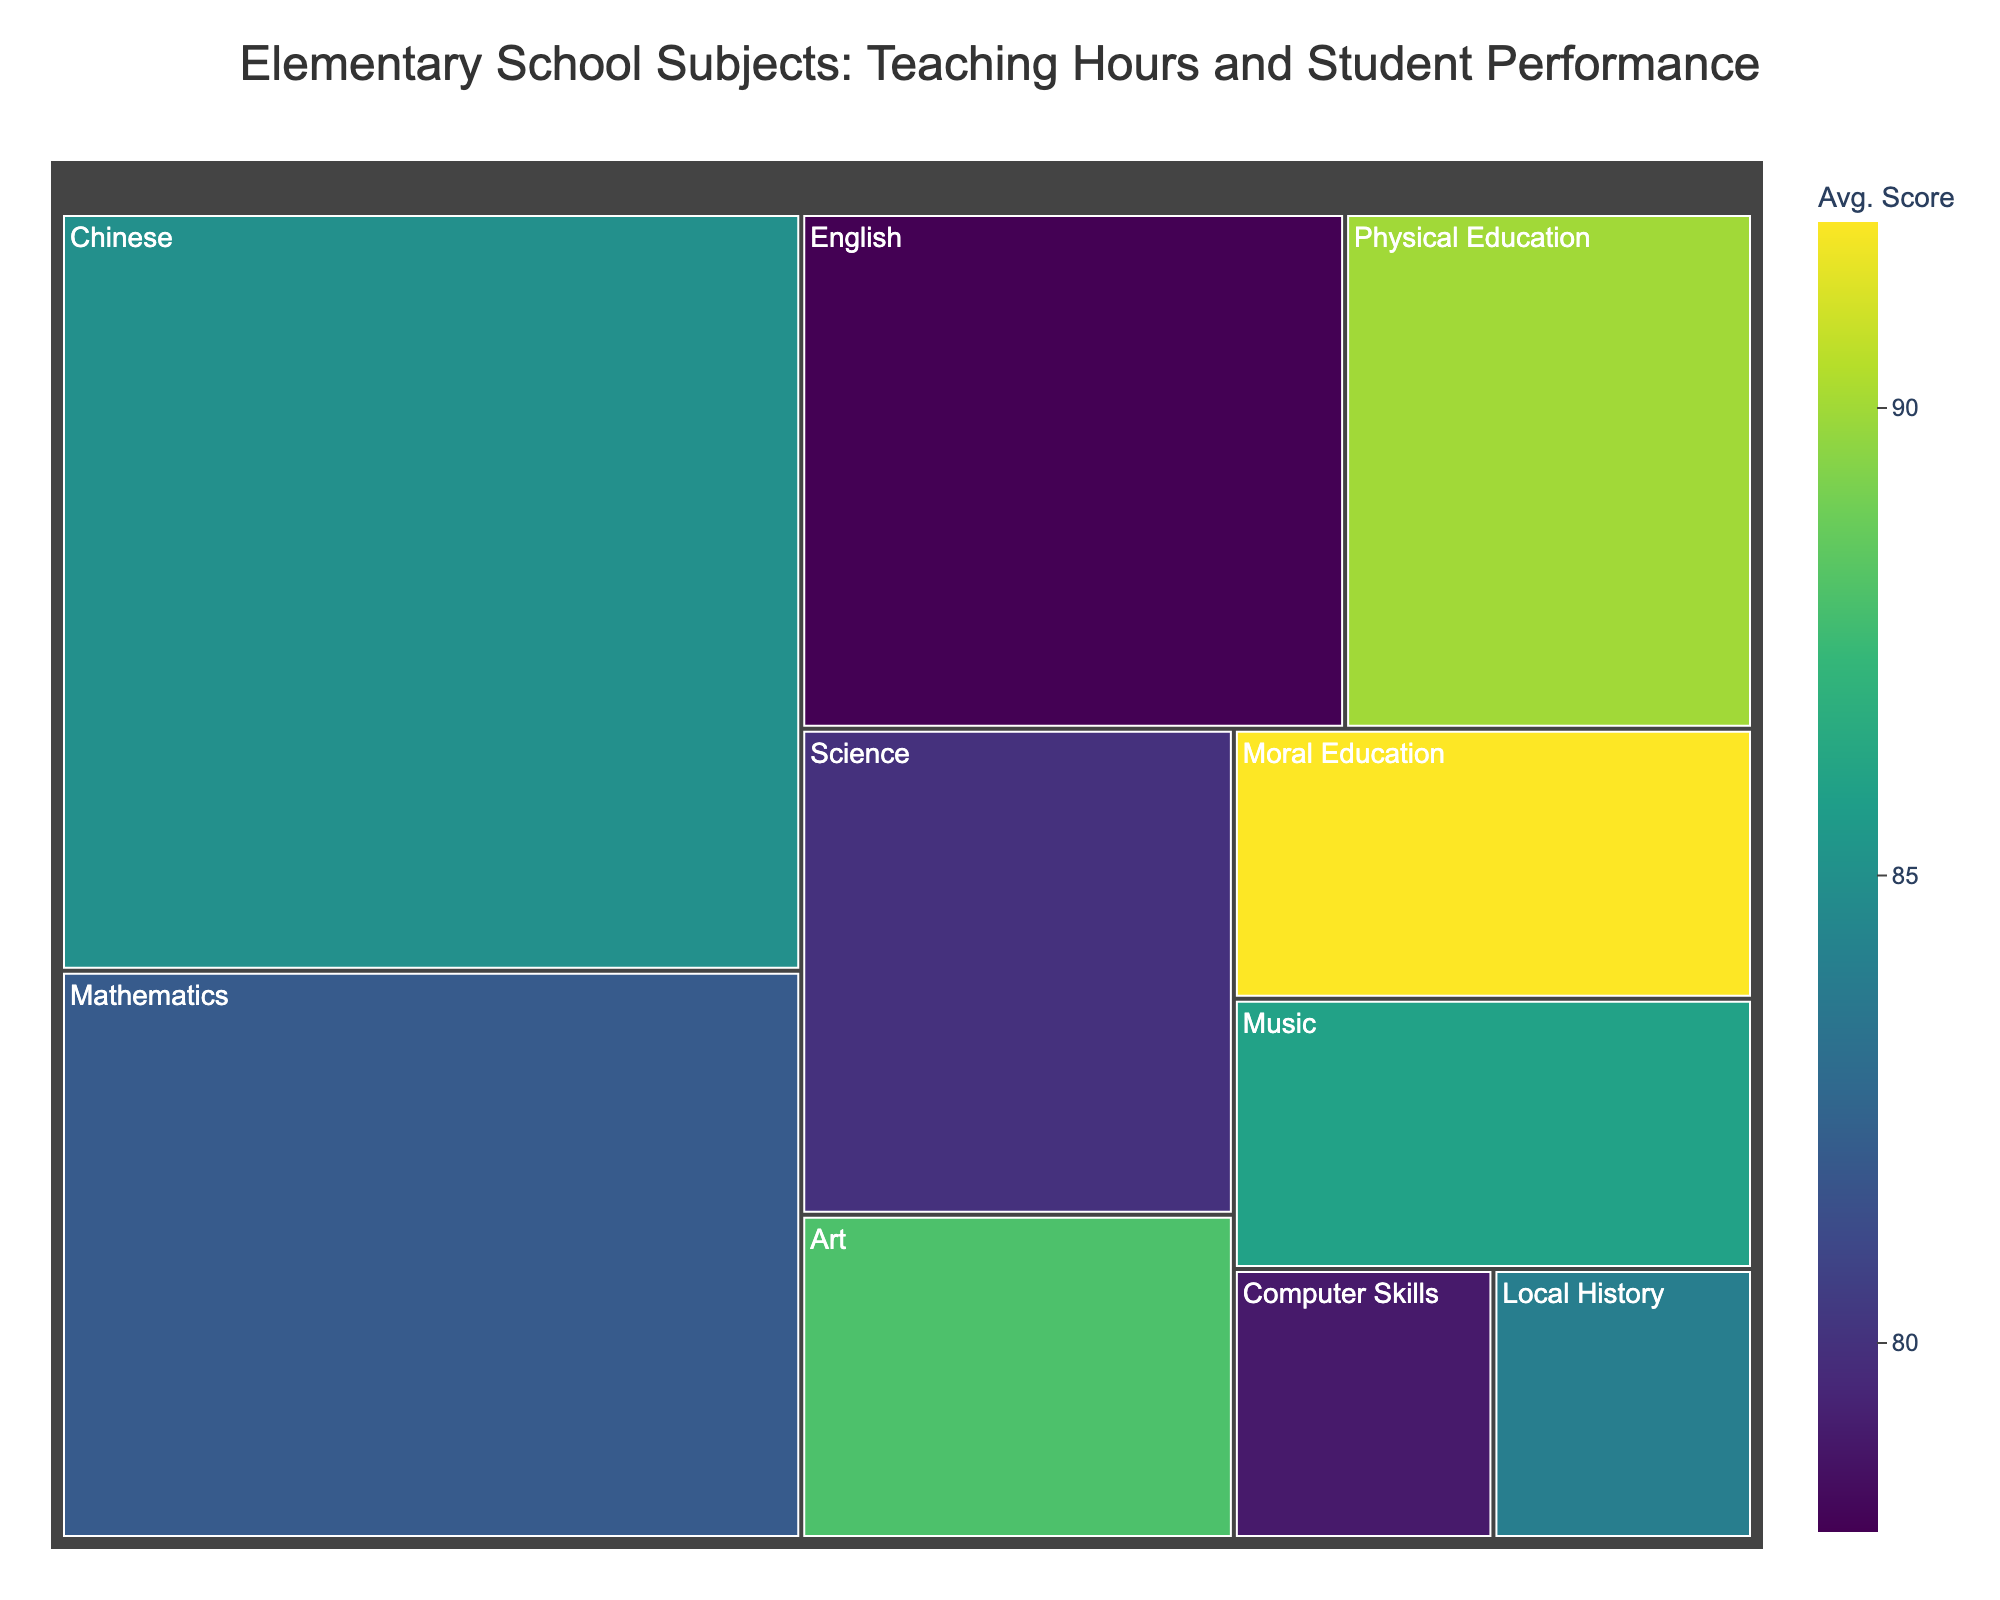What's the title of the figure? The title is usually displayed at the top of the figure. For this treemap, the title is clearly shown as 'Elementary School Subjects: Teaching Hours and Student Performance'.
Answer: Elementary School Subjects: Teaching Hours and Student Performance Which subject is allocated the most teaching hours per week? By examining the size of the tiles in the treemap, the largest tile corresponds to the subject with the most hours. Here, 'Chinese' has the largest tile, indicating it has the most teaching hours per week.
Answer: Chinese What is the average score for 'Physical Education'? Hovering over the tile for 'Physical Education' will display its detailed information, including the average score, which is 90.
Answer: 90 Which two subjects have the same number of teaching hours per week? By looking at the sizes of the tiles, we can see that 'Science' and 'Physical Education' have tiles of the same size, indicating they both have 3 hours per week. Additionally, 'Art', 'Music', and 'Moral Education' also share the same size, with 2 hours per week each.
Answer: Science and Physical Education; Art, Music, and Moral Education What is the lowest average score among the subjects? By examining the color gradient or hovering over each tile, the lowest score is for 'Computer Skills', which has an average score of 79.
Answer: Computer Skills How many subjects have an average score above 85? To find this, look at the colors of the tiles and hover to check the scores. Subjects with scores over 85 are 'Chinese', 'Physical Education', 'Art', 'Music', 'Moral Education', and 'Local History'. There are 6 such subjects.
Answer: 6 Which subject has the fewest teaching hours per week and what is its average score? The smallest tile corresponds to the subject with the fewest teaching hours, which is 'Local History' and 'Computer Skills', both with 1 hour. The average scores are 84 and 79, respectively.
Answer: Local History and Computer Skills; 84 and 79 How does the performance in 'Mathematics' compare to 'Science'? By comparing the average scores of both subjects, 'Mathematics' has an average score of 82, while 'Science' has an average score of 80.
Answer: Mathematics performance is higher What is the sum of teaching hours for 'Art' and 'Music'? Adding the hours for 'Art' (2) and 'Music' (2) results in a total of 4 hours per week.
Answer: 4 What's the range of average scores across all subjects? To determine this, subtract the lowest score (79 for 'Computer Skills') from the highest score (92 for 'Moral Education'). The range is 92 - 79 = 13.
Answer: 13 